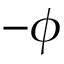Convert formula to latex. <formula><loc_0><loc_0><loc_500><loc_500>- \phi</formula> 